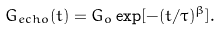Convert formula to latex. <formula><loc_0><loc_0><loc_500><loc_500>G _ { e c h o } ( t ) = G _ { o } \exp [ - ( t / \tau ) ^ { \beta } ] .</formula> 